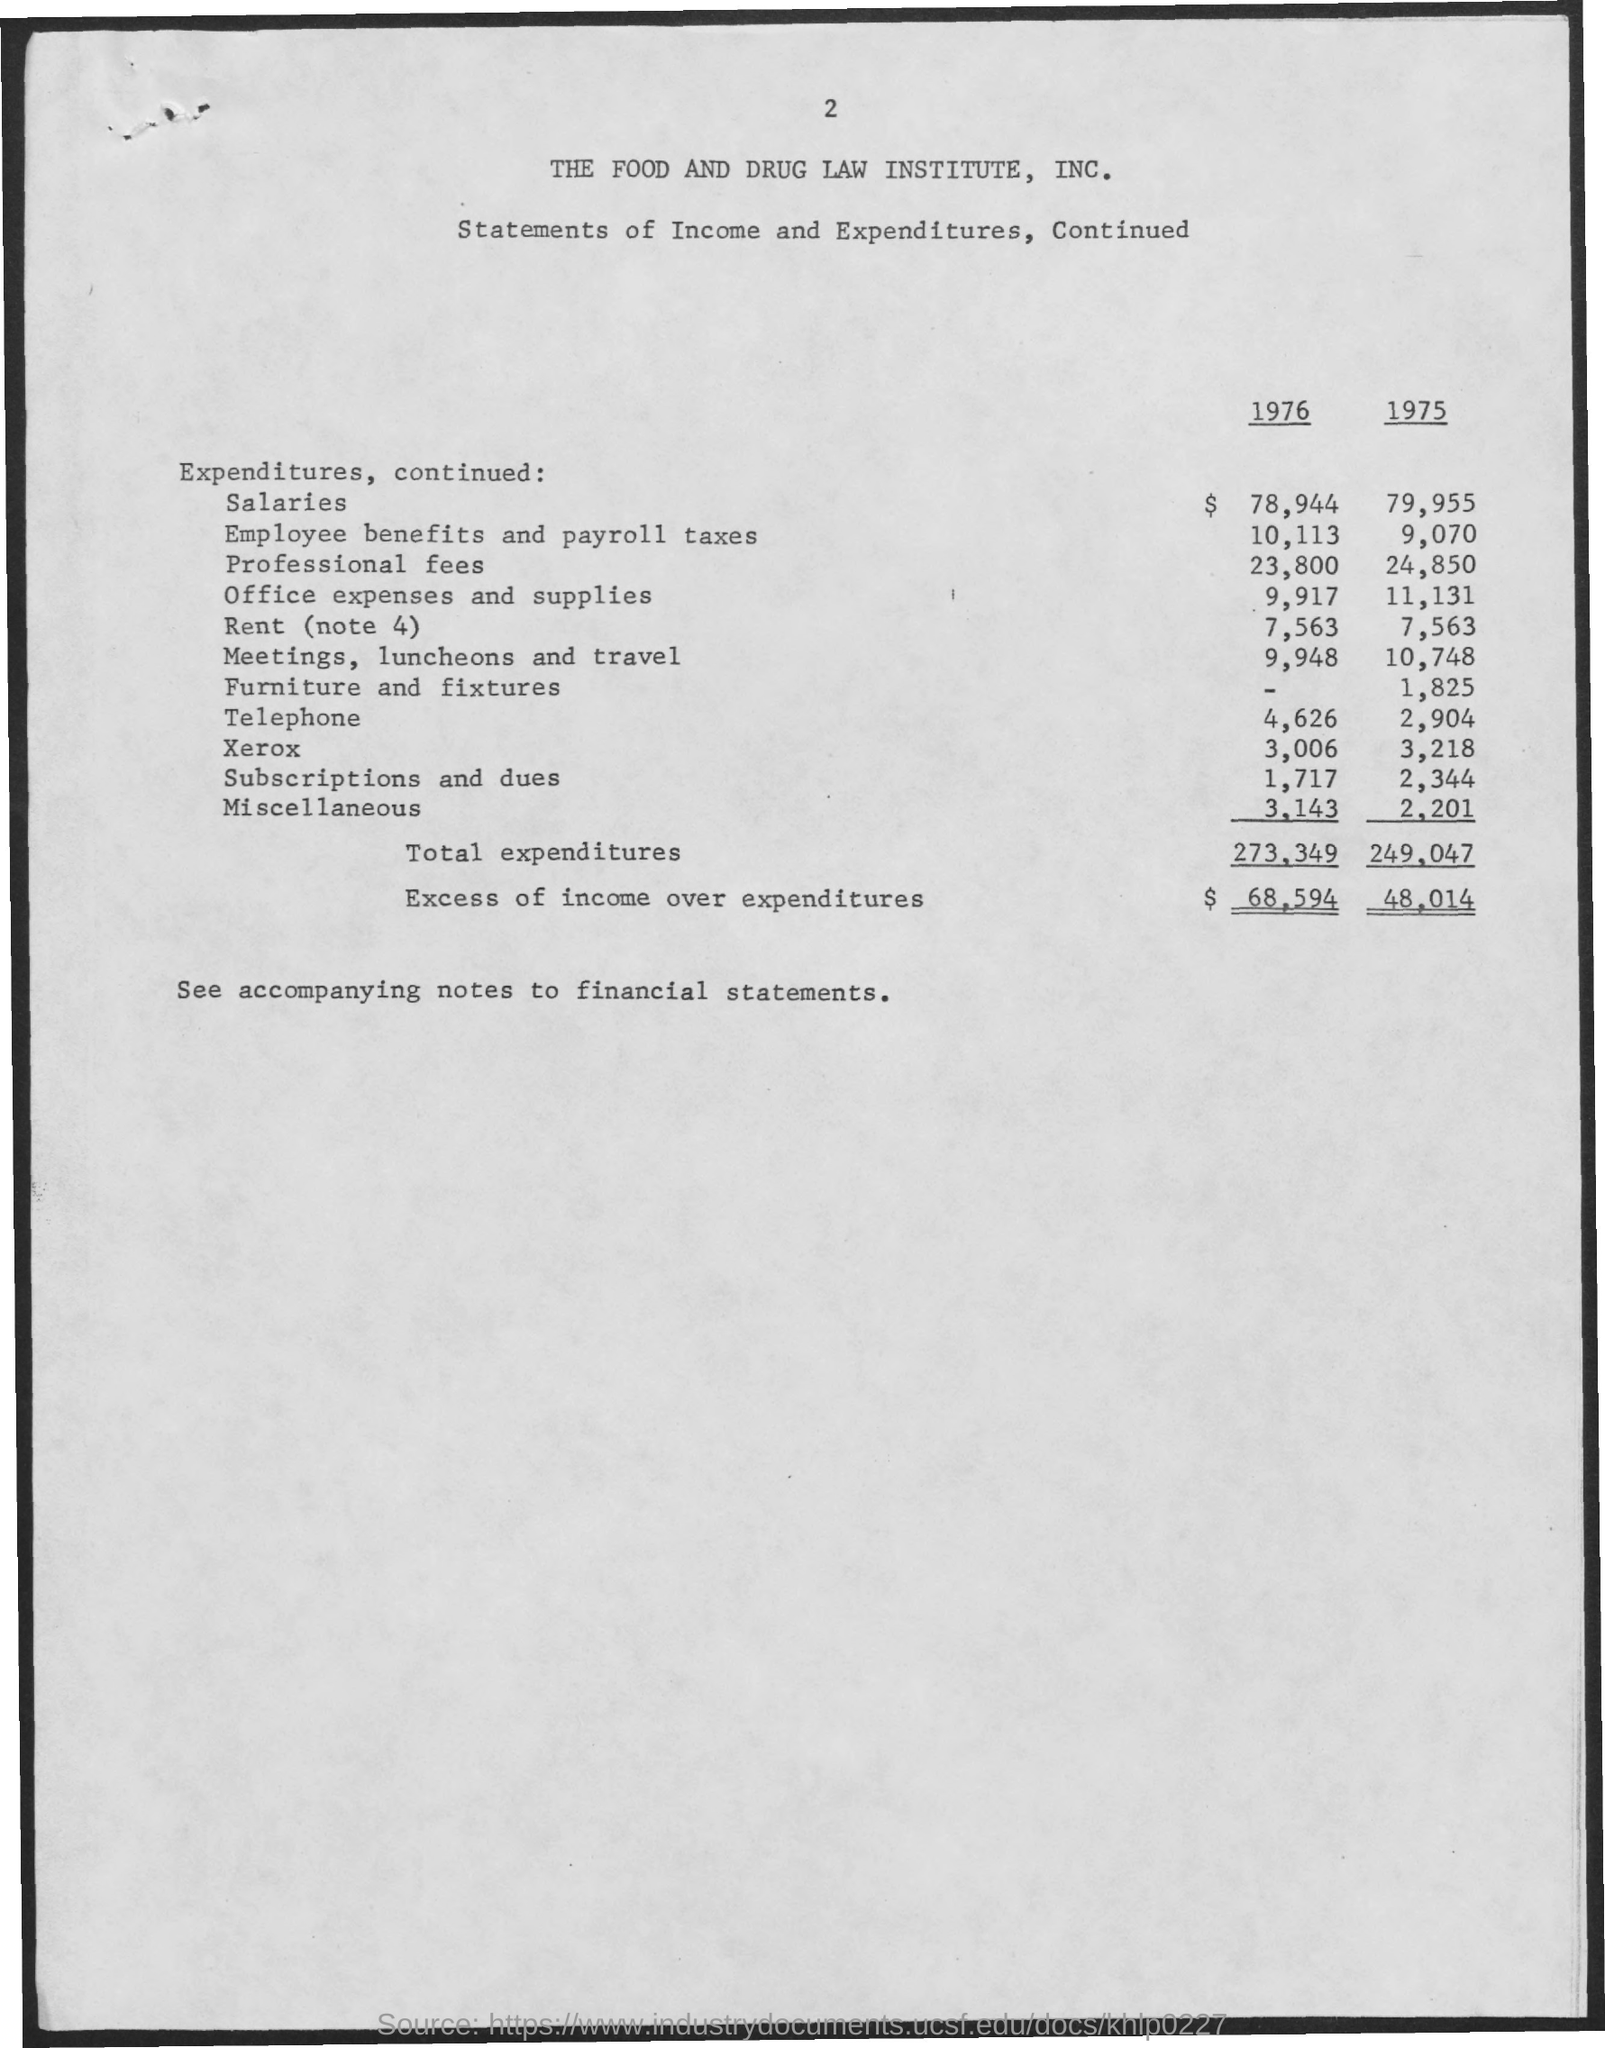What is the name of the institute mentioned in the given page ?
Make the answer very short. The food and drug law institute. What is the amount of salaries given in the year 1976 ?
Offer a terse response. 78,944. What is the amount for employee benefits and payroll taxes in the year 1975 ?
Your answer should be very brief. 9,070. What is the amount for professional fees in the year 1976 ?
Offer a terse response. 23,800. What is the amount of total expenditures in the year 1976 ?
Keep it short and to the point. $ 273,349. What is the amount of total expenditures in the year 1975 ?
Ensure brevity in your answer.  249,047. What is the amount for furniture and fixtures in the year 1975 ?
Provide a succinct answer. $ 1,825. What is the amount of excess of income over expenditures in the year 1976 ?
Your response must be concise. $ 68,594. What is the amount of excess of income over expenditures in the year 1975 ?
Keep it short and to the point. $ 48,014. 